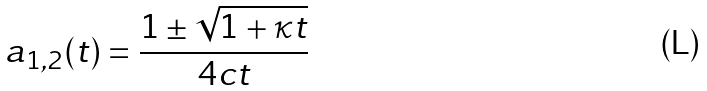<formula> <loc_0><loc_0><loc_500><loc_500>a _ { 1 , 2 } ( t ) = \frac { 1 \pm \sqrt { 1 + \kappa t } } { 4 c t }</formula> 